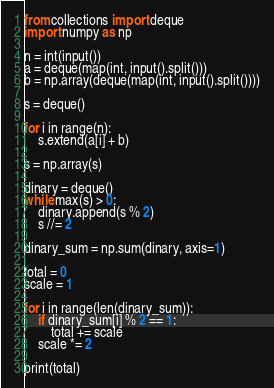Convert code to text. <code><loc_0><loc_0><loc_500><loc_500><_Python_>from collections import deque
import numpy as np

n = int(input())
a = deque(map(int, input().split()))
b = np.array(deque(map(int, input().split())))

s = deque()

for i in range(n):
    s.extend(a[i] + b)

s = np.array(s)

dinary = deque()
while max(s) > 0:
    dinary.append(s % 2)
    s //= 2

dinary_sum = np.sum(dinary, axis=1)

total = 0
scale = 1

for i in range(len(dinary_sum)):
    if dinary_sum[i] % 2 == 1:
        total += scale
    scale *= 2

print(total)
</code> 